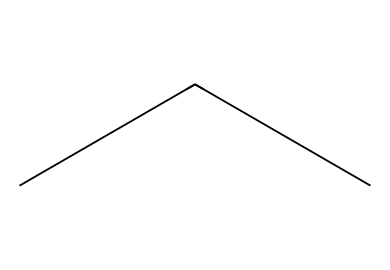What is the common name of this refrigerant? This chemical has the SMILES representation 'CCC', indicating it is propane, which is commonly used as an eco-friendly refrigerant.
Answer: propane How many carbon atoms are in this structure? The SMILES 'CCC' represents a structure with three consecutive carbon atoms.
Answer: three What type of bonding is present in propane? In propane’s structure, the carbon atoms are connected by single bonds, meaning it contains only sigma bonds.
Answer: single Is propane a saturated or unsaturated hydrocarbon? Since propane has only single bonds and no double or triple bonds, it qualifies as a saturated hydrocarbon.
Answer: saturated What is the environmental advantage of using propane as a refrigerant? Propane has a low Global Warming Potential (GWP) compared to many traditional refrigerants, making it more environmentally friendly.
Answer: low GWP How many hydrogen atoms are present in propane? In propane, for each of the three carbon atoms, there are eight total hydrogen atoms, evident from its formula C3H8.
Answer: eight What is the state of propane at room temperature? Propane is typically a gas at room temperature due to its molecular structure and low boiling point.
Answer: gas 